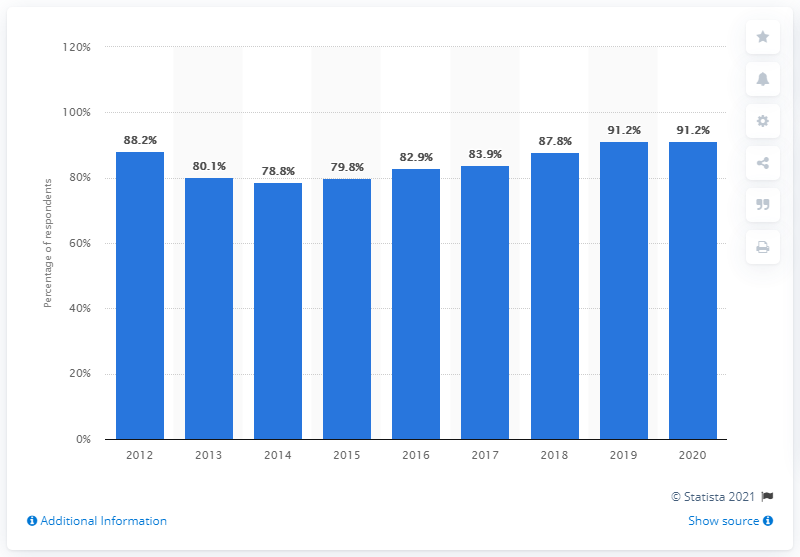Specify some key components in this picture. In the most recent year, the internet usage rate of internet users aged three to nine years in South Korea was 91.2%. 